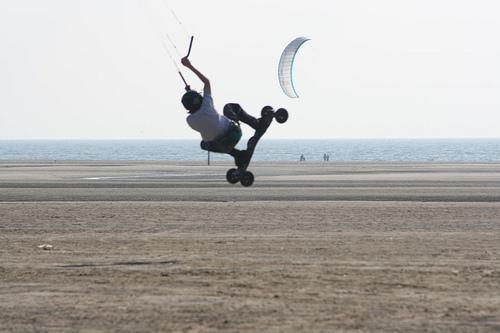How many people are in the scene?
Give a very brief answer. 1. 